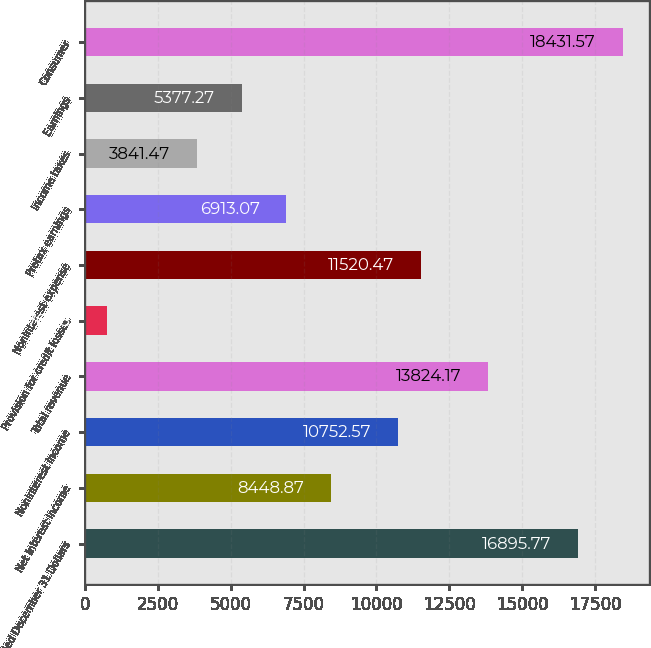Convert chart. <chart><loc_0><loc_0><loc_500><loc_500><bar_chart><fcel>Year ended December 31 Dollars<fcel>Net interest income<fcel>Noninterest income<fcel>Total revenue<fcel>Provision for credit losses<fcel>Noninterest expense<fcel>Pretax earnings<fcel>Income taxes<fcel>Earnings<fcel>Consumer<nl><fcel>16895.8<fcel>8448.87<fcel>10752.6<fcel>13824.2<fcel>769.87<fcel>11520.5<fcel>6913.07<fcel>3841.47<fcel>5377.27<fcel>18431.6<nl></chart> 